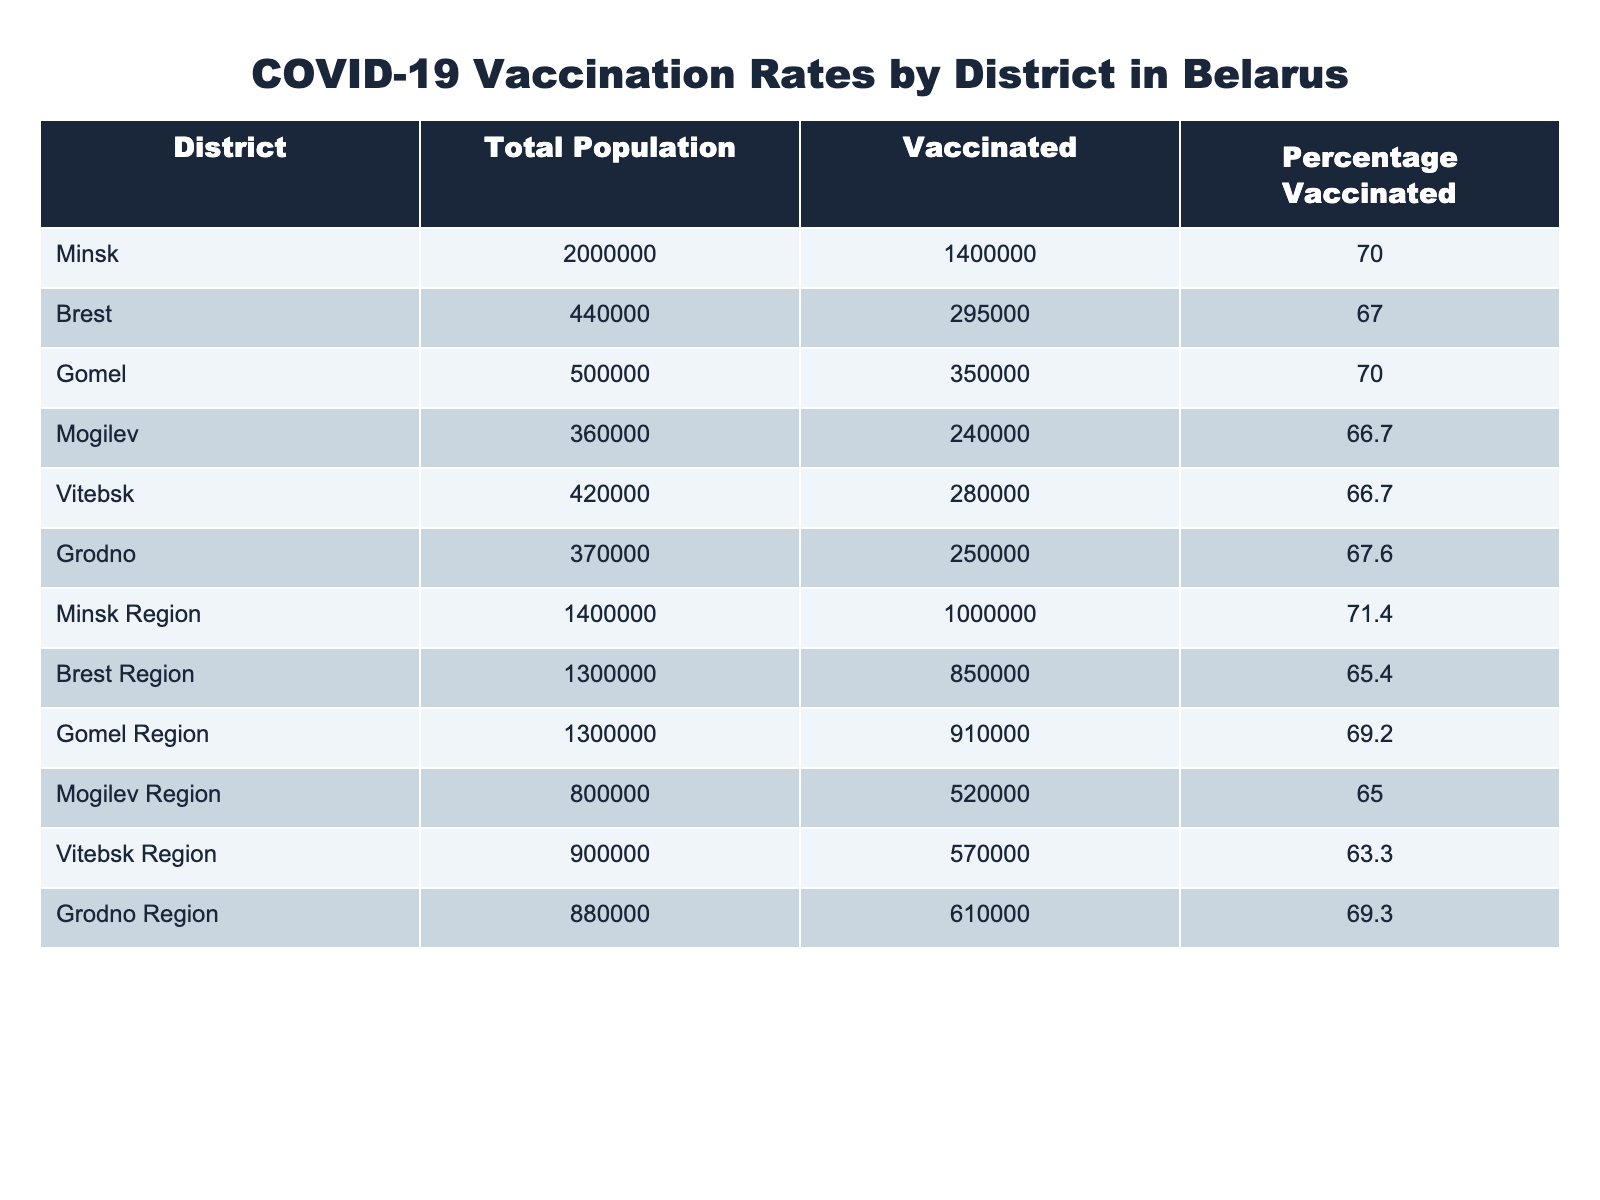What's the vaccination percentage in Minsk? From the table, the column for "Percentage Vaccinated" shows that the percentage for Minsk is 70.0%.
Answer: 70.0% Which district has the highest vaccination rate? By examining the "Percentage Vaccinated" column, both Minsk and Gomel have the highest rate at 70.0%.
Answer: Minsk and Gomel What is the total vaccinated population in the Grodno Region? In the Grodno Region, the "Vaccinated" column indicates that 610,000 people have received the vaccine.
Answer: 610,000 What is the difference in vaccination rates between the best-performing district (Minsk Region) and the worst-performing region (Vitebsk Region)? The vaccination rate for Minsk Region is 71.4%, and for Vitebsk Region, it is 63.3%. The difference is 71.4% - 63.3% = 8.1%.
Answer: 8.1% What is the average vaccination percentage across all districts? To find the average, we sum all the percentages: (70.0 + 67.0 + 70.0 + 66.7 + 66.7 + 67.6 + 71.4 + 65.4 + 69.2 + 65.0 + 63.3 + 69.3)/12 = 67.85%.
Answer: 67.85% Is it true that the vaccinated population in Brest Region is more than 800,000? According to the table, the vaccinated population in Brest Region is 850,000, which is indeed more than 800,000.
Answer: Yes Which region has the least vaccinated population in terms of total people vaccinated? By comparing the total vaccinated populations, Mogilev Region has the least with 520,000 vaccinated individuals.
Answer: Mogilev Region What percentage of the total population in Vitebsk Region is vaccinated? The table shows that the vaccinated individuals in Vitebsk Region are 570,000 and the total population is 900,000. The percentage is (570,000 / 900,000) * 100 = 63.33%.
Answer: 63.33% If the vaccination rate in Grodno is 67.6%, how many people remain unvaccinated in Grodno? In Grodno, the total population is 370,000; hence, the unvaccinated count is 370,000 - 250,000 = 120,000.
Answer: 120,000 How does the vaccination percentage in Mogilev compare to the average vaccination percentage? Mogilev has a vaccination percentage of 66.7%, which is below the average of 67.85%.
Answer: Below average What is the total population of the Gomel Region? The Gomel Region has a total population of 1,300,000 as listed in the table.
Answer: 1,300,000 